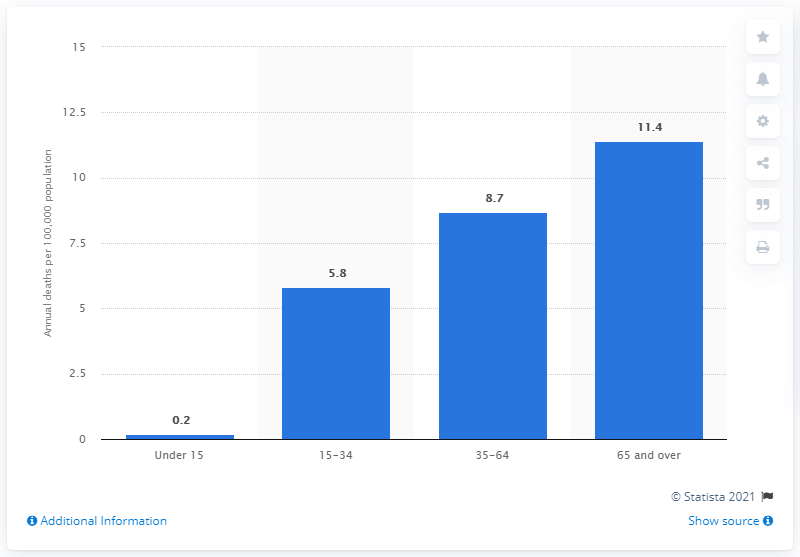Identify some key points in this picture. According to data, the average number of gun deaths per 100,000 people is 11.4. The corresponding rate among the population aged 15 to 34 was 5.8%. 